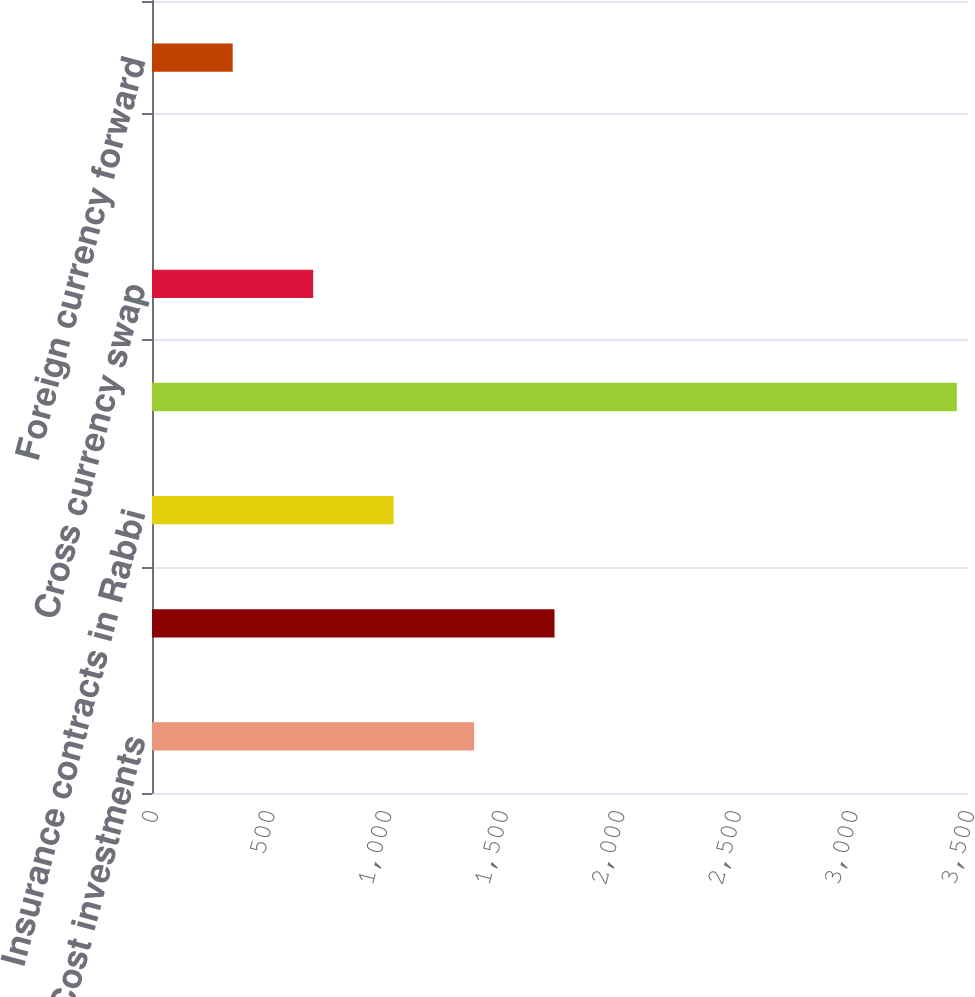Convert chart. <chart><loc_0><loc_0><loc_500><loc_500><bar_chart><fcel>Cost investments<fcel>Marketable securities<fcel>Insurance contracts in Rabbi<fcel>Long-term debt<fcel>Cross currency swap<fcel>Interest rate swap<fcel>Foreign currency forward<nl><fcel>1381.4<fcel>1726.5<fcel>1036.3<fcel>3452<fcel>691.2<fcel>1<fcel>346.1<nl></chart> 